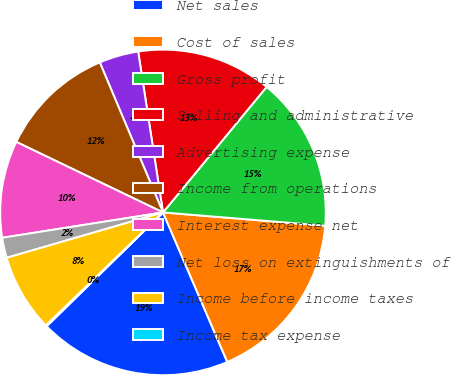Convert chart. <chart><loc_0><loc_0><loc_500><loc_500><pie_chart><fcel>Net sales<fcel>Cost of sales<fcel>Gross profit<fcel>Selling and administrative<fcel>Advertising expense<fcel>Income from operations<fcel>Interest expense net<fcel>Net loss on extinguishments of<fcel>Income before income taxes<fcel>Income tax expense<nl><fcel>19.13%<fcel>17.23%<fcel>15.32%<fcel>13.42%<fcel>3.91%<fcel>11.52%<fcel>9.62%<fcel>2.01%<fcel>7.72%<fcel>0.11%<nl></chart> 